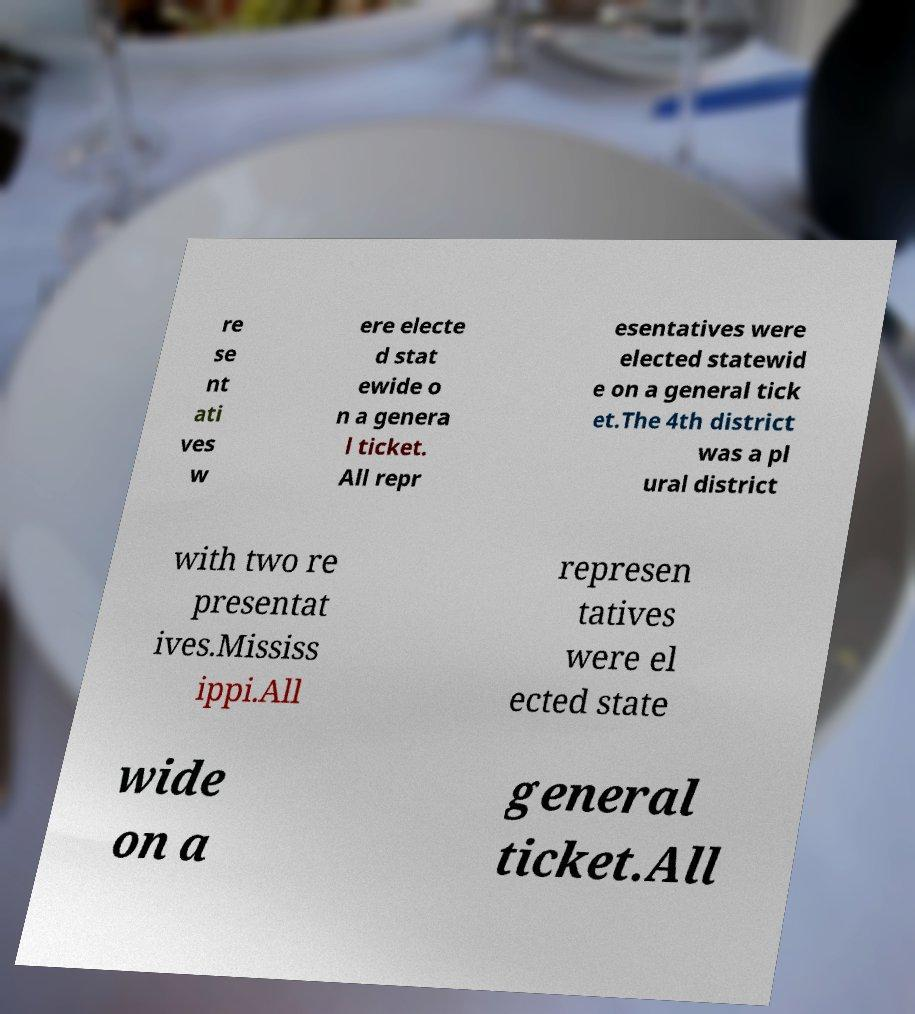Could you extract and type out the text from this image? re se nt ati ves w ere electe d stat ewide o n a genera l ticket. All repr esentatives were elected statewid e on a general tick et.The 4th district was a pl ural district with two re presentat ives.Mississ ippi.All represen tatives were el ected state wide on a general ticket.All 